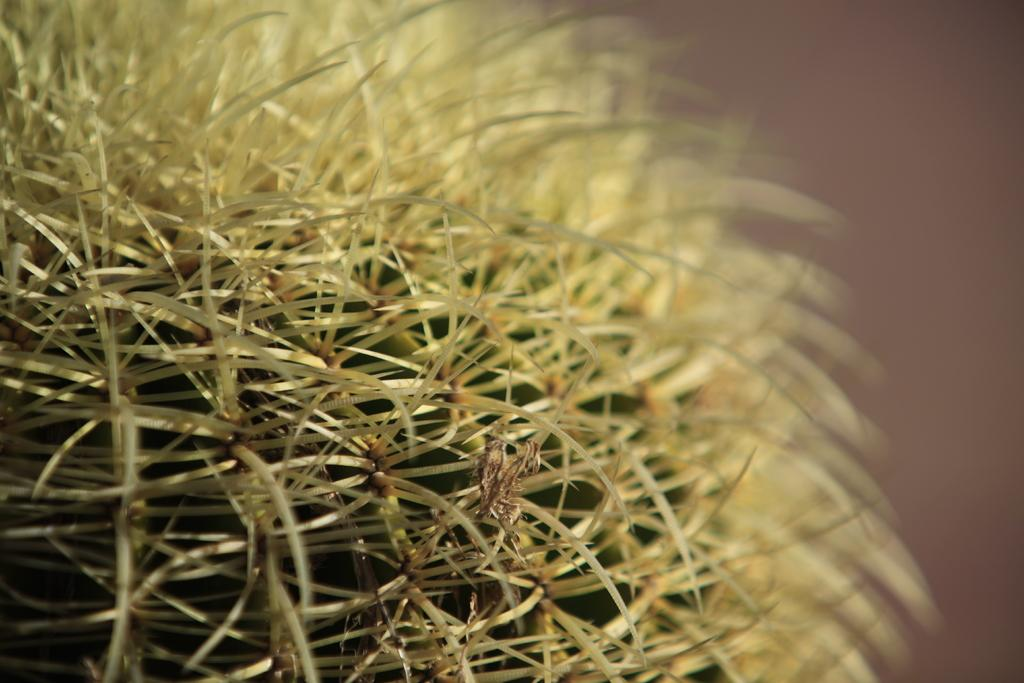What type of plant is in the image? There is a cactus plant in the image. What type of lace can be seen on the cactus plant in the image? There is no lace present on the cactus plant in the image. 